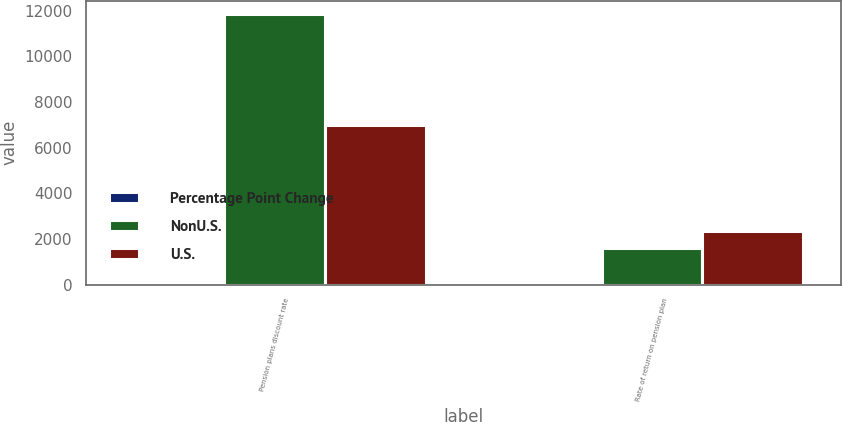<chart> <loc_0><loc_0><loc_500><loc_500><stacked_bar_chart><ecel><fcel>Pension plans discount rate<fcel>Rate of return on pension plan<nl><fcel>Percentage Point Change<fcel>0.25<fcel>1<nl><fcel>NonU.S.<fcel>11836<fcel>1592<nl><fcel>U.S.<fcel>6969<fcel>2343<nl></chart> 